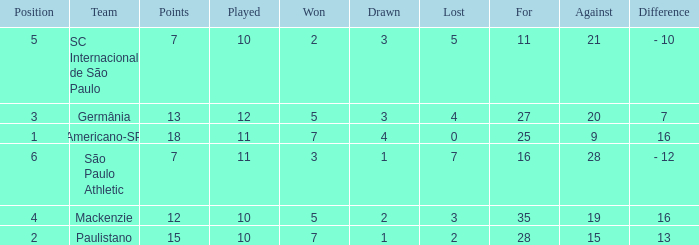Name the points for paulistano 15.0. 